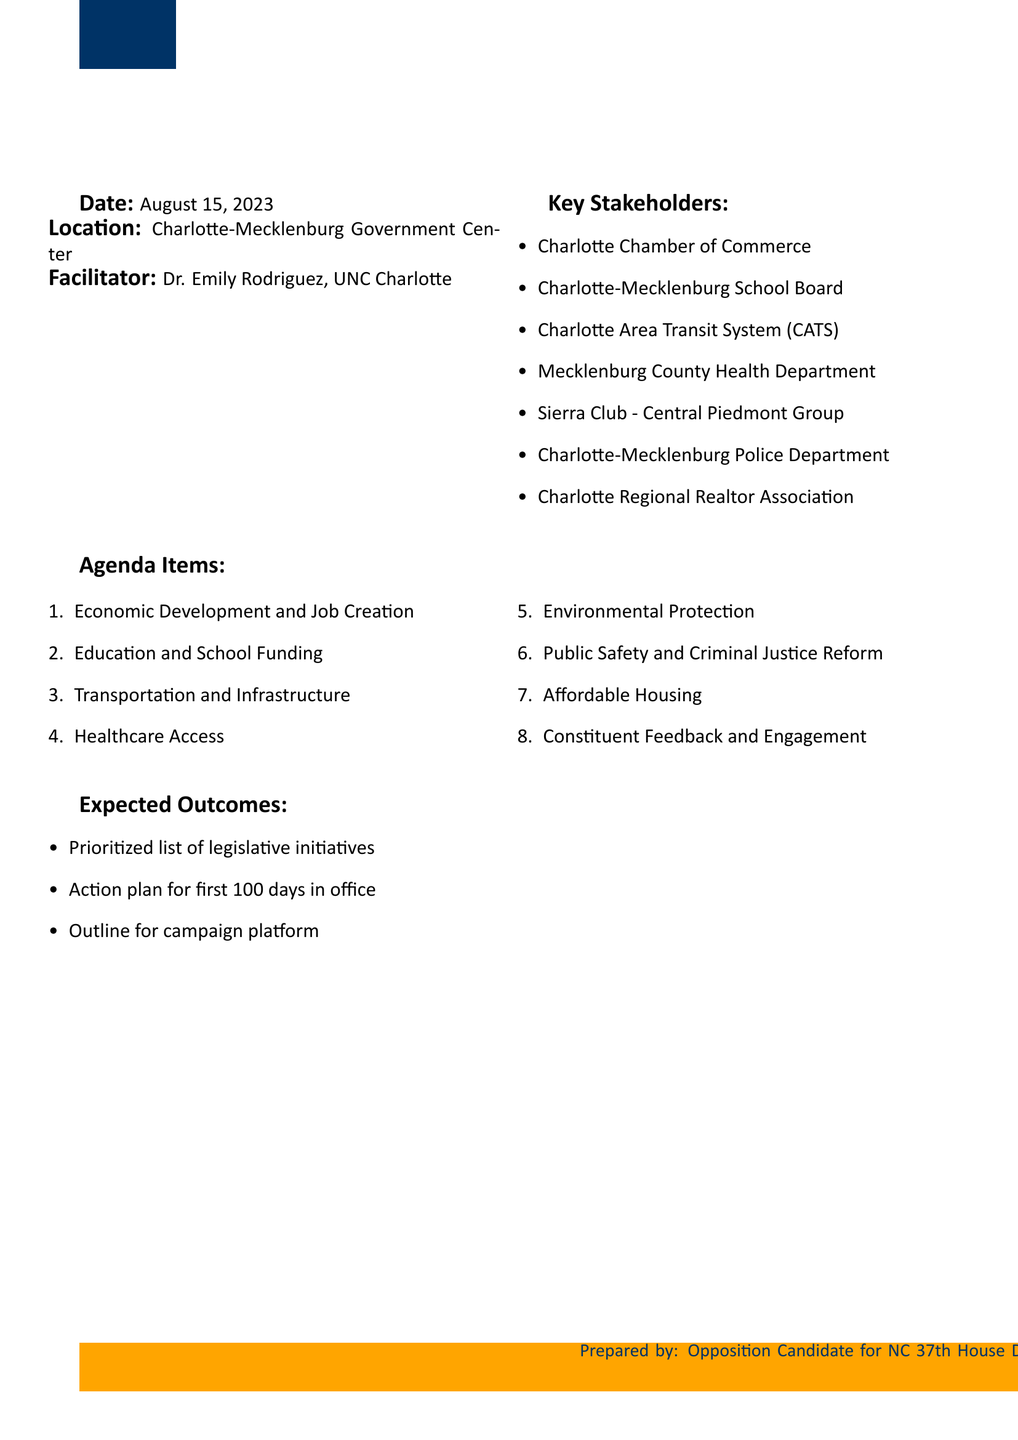What is the date of the session? The date of the session is mentioned clearly in the document.
Answer: August 15, 2023 Who is the facilitator of the session? The document specifies who will facilitate this legislative session.
Answer: Dr. Emily Rodriguez, Political Science Professor at UNC Charlotte What is the location of the meeting? The location is stated outright in the agenda document.
Answer: Charlotte-Mecklenburg Government Center How many agenda items are listed in the document? The number of agenda items can be counted directly from the list provided.
Answer: Eight What is one of the key stakeholders mentioned? The document lists multiple stakeholders, and one can be cited.
Answer: Charlotte Chamber of Commerce What is one expected outcome from the session? The document provides several expected outcomes that can be explicitly stated.
Answer: Prioritized list of legislative initiatives Which agenda item addresses education issues? The specific agenda items relate to education and can be checked in the document.
Answer: Education and School Funding Which topic includes environmental protection measures? The document clearly identifies topics related to environmental issues.
Answer: Environmental Protection 